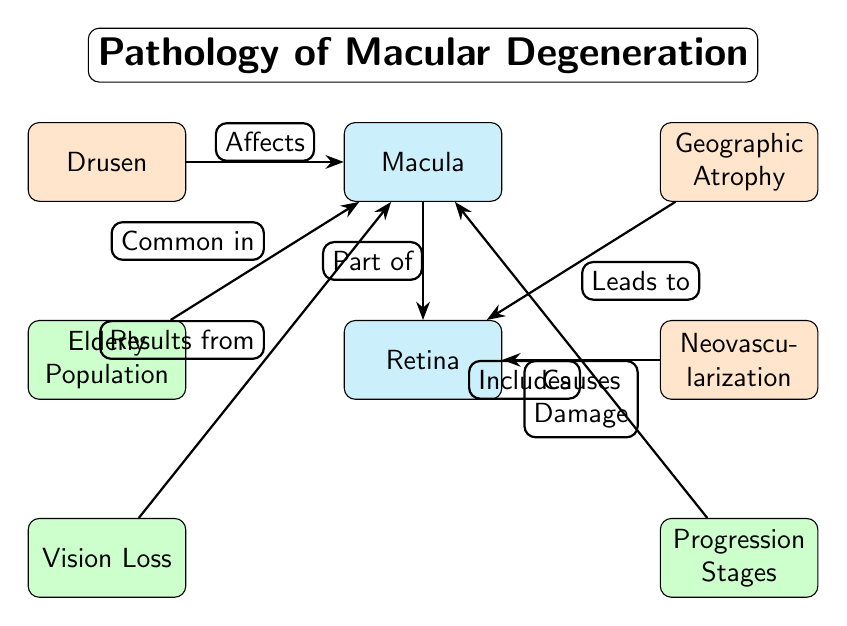What is the primary structure affected by macular degeneration? The diagram indicates that the macula is the main area impacted by macular degeneration, as it is the central node in the diagram.
Answer: Macula What does drusen affect? According to the diagram, drusen affects the macula, as shown by the connecting edge labeled "Affects."
Answer: Macula Which condition leads to damage of the retina? The diagram indicates that neovascularization causes damage to the retina, as established by the edge labeled "Causes Damage."
Answer: Neovascularization What common population group is the condition associated with? The diagram reveals that the elderly population is commonly associated with macular degeneration, indicated by the edge labeled "Common in."
Answer: Elderly Population How many secondary nodes are there in the diagram? By counting the nodes, we see there are three secondary nodes (drusen, geographic atrophy, neovascularization).
Answer: 3 What is the result of vision loss in the diagram? The diagram shows that vision loss results from changes in the macula, as indicated by the edge labeled "Results from."
Answer: Macula Which progression stage is included in the condition's pathway? The diagram marks 'Progression Stages' as included within the influence of the macula, indicated by the edge labeled "Includes."
Answer: Progression Stages What is the relationship between geographic atrophy and the retina? The diagram states that geographic atrophy leads to changes in the retina, as shown by the connecting edge labeled "Leads to."
Answer: Retina Which process is indicated as a consequence of damage caused to the retina? The diagram shows that damage to the retina ultimately results in vision loss, represented by the edge labeled "Results from."
Answer: Vision Loss 